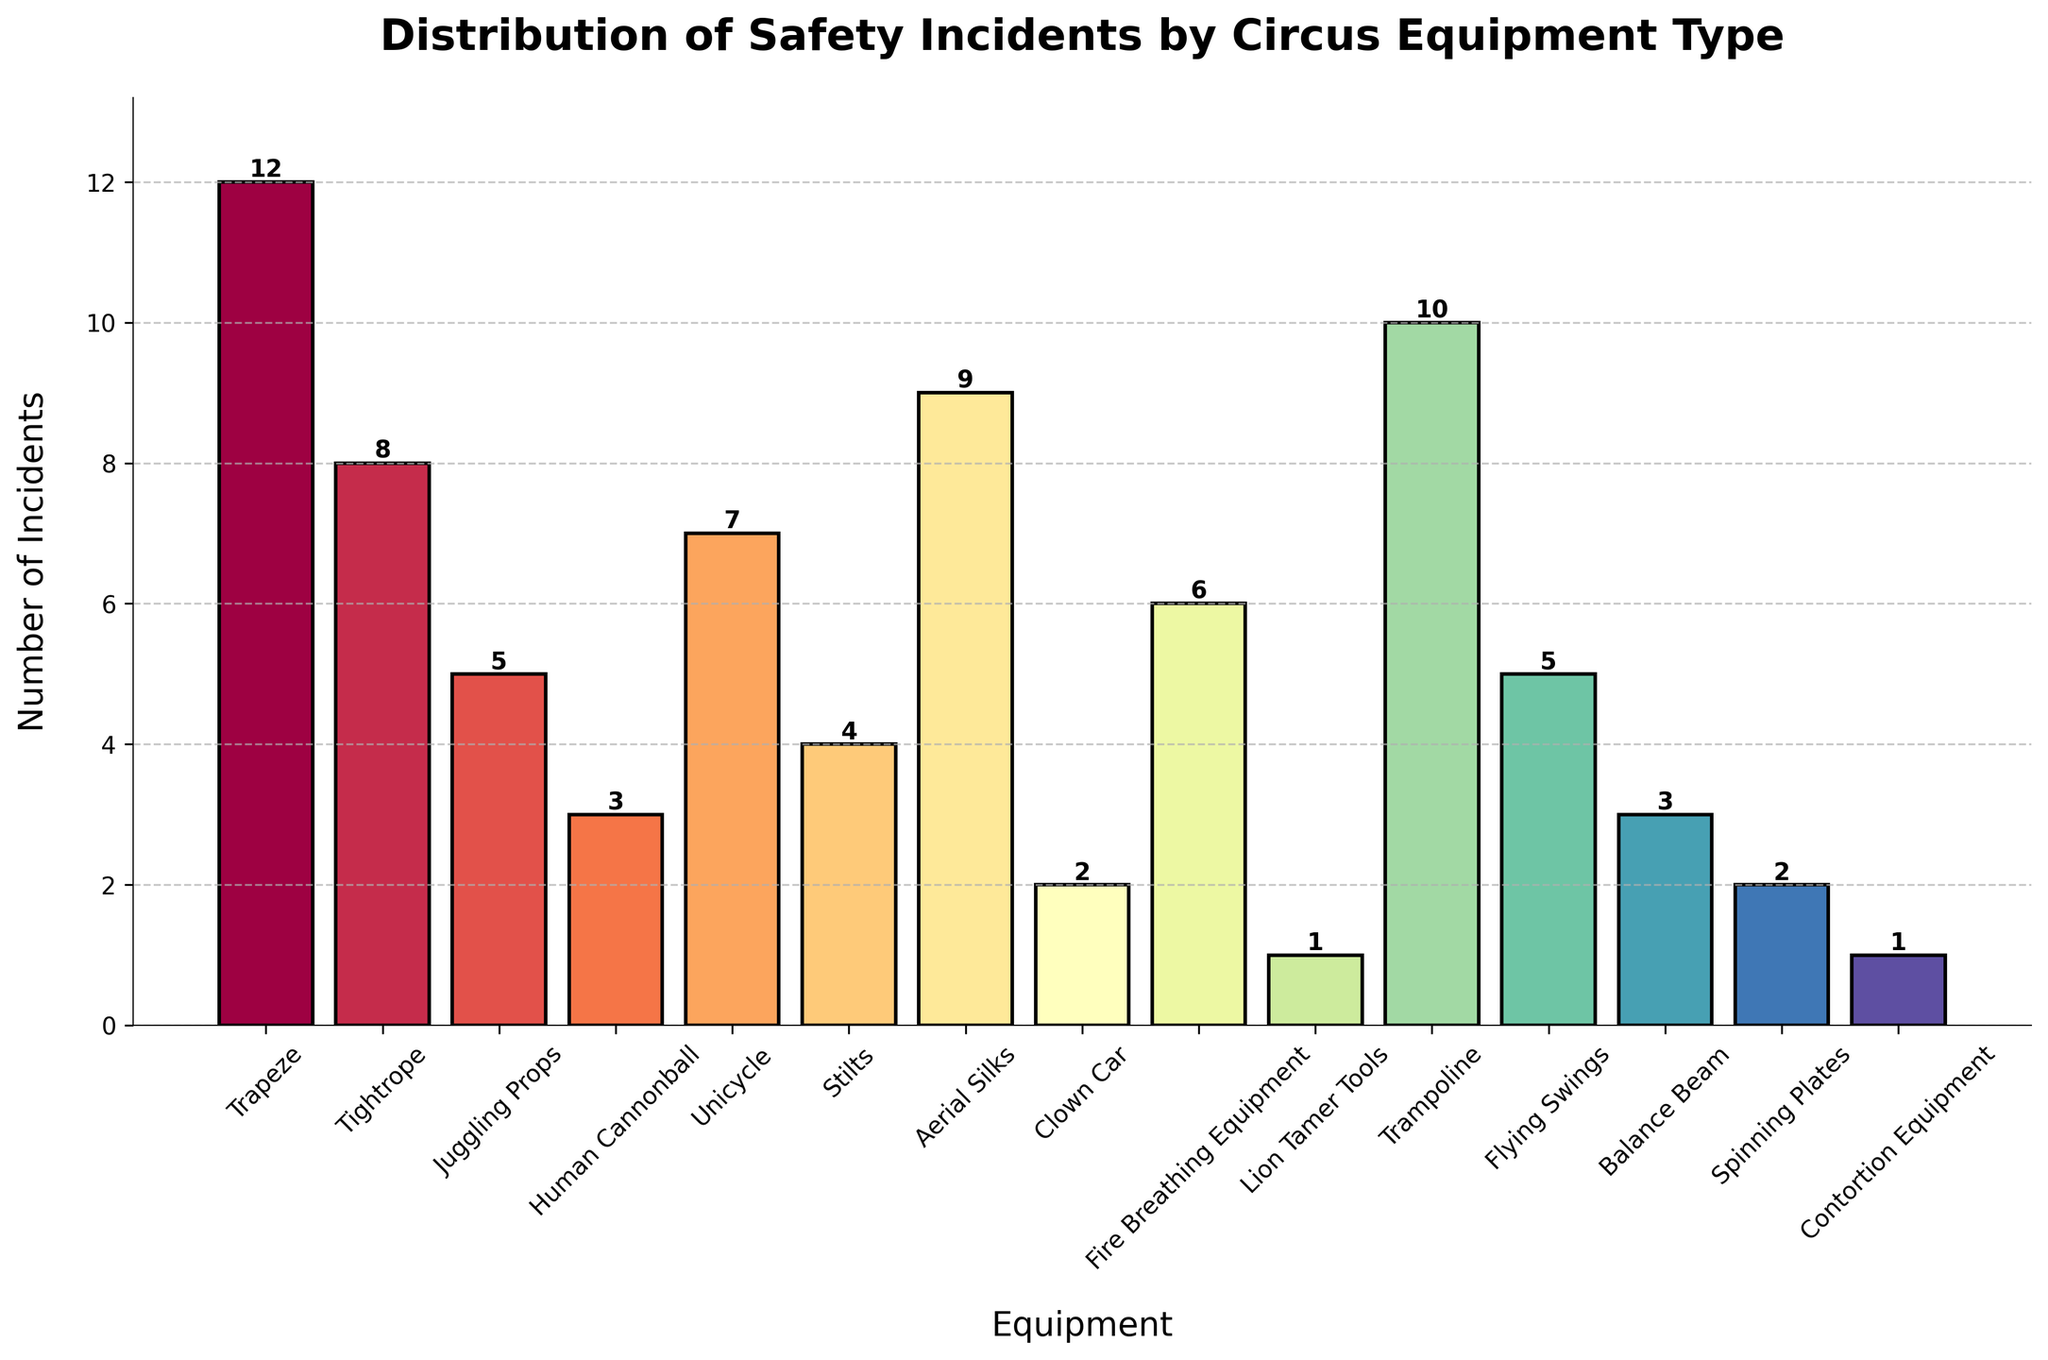Which equipment type has the highest number of incidents? The tallest bar in the chart represents the equipment type with the highest number of incidents. The "Trapeze" bar is the tallest.
Answer: Trapeze Which equipment type has the fewest incidents? The shortest bar in the chart represents the equipment type with the fewest incidents. The "Lion Tamer Tools" and "Contortion Equipment" bars are the shortest.
Answer: Lion Tamer Tools and Contortion Equipment How many more incidents does the "Trampoline" have compared to the "Unicycle"? Locate the bars for "Trampoline" and "Unicycle". "Trampoline" has 10 incidents and "Unicycle" has 7. The difference is 10 - 7.
Answer: 3 Which equipment types have exactly 5 incidents? Identify the bars with the height corresponding to 5 incidents. The "Juggling Props" and "Flying Swings" bars match this criterion.
Answer: Juggling Props and Flying Swings What's the total number of incidents for "Aerial Silks", "Fire Breathing Equipment", and "Tightrope"? Sum the incidents for these equipment types. "Aerial Silks" has 9 incidents, "Fire Breathing Equipment" has 6, and "Tightrope" has 8. The total is 9 + 6 + 8.
Answer: 23 Which equipment types have bars colored similarly? Identify bars with visually similar colors through the colormap used. For example, if "Trapeze" and "Aerial Silks" appear in shades of purple. This can indicate trends or categorizations.
Answer: Answer varies based on specific colors Which equipment type has fewer incidents: "Fire Breathing Equipment" or "Flying Swings"? Compare the heights of the bars for "Fire Breathing Equipment" and "Flying Swings". The bar for "Flying Swings" has 5 incidents and the one for "Fire Breathing Equipment" has 6.
Answer: Flying Swings How many more incidents are there in the "Trapeze" compared to the combined incidents from "Spinning Plates" and "Clown Car"? "Trapeze" has 12 incidents, "Spinning Plates" has 2, and "Clown Car" has 2. Sum the incidents for "Spinning Plates" and "Clown Car" (2 + 2 = 4), then find the difference (12 - 4).
Answer: 8 What's the average number of incidents per equipment type? Sum the total number of incidents from all equipment and divide by the number of equipment types. The total is 75 incidents across 15 equipment types. The average is 75 / 15.
Answer: 5 Are there more incidents in "Trampoline" than in "Aerial Silks" and "Unicycle" combined? Sum the incidents for "Aerial Silks" (9) and "Unicycle" (7) which is 16. Compare this with "Trampoline" which has 10 incidents.
Answer: No 